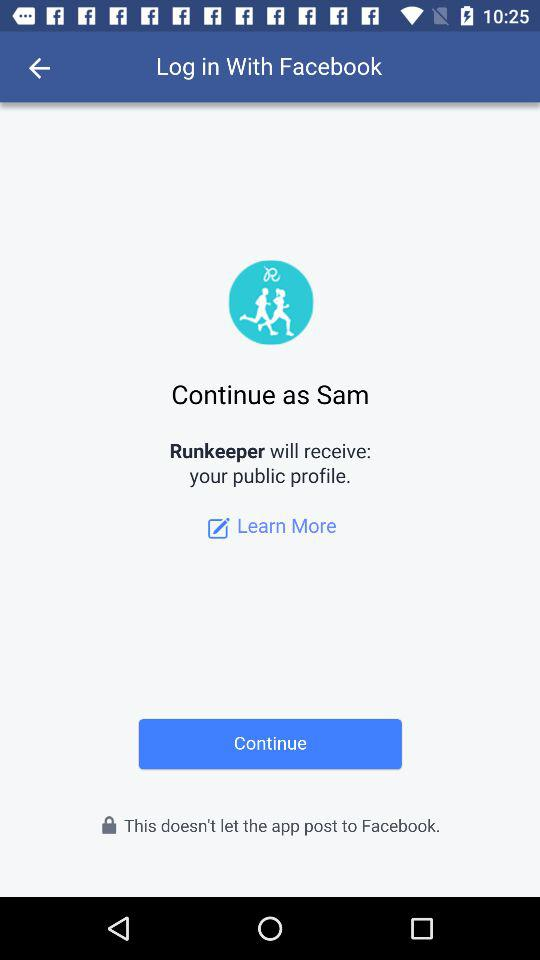What is the user name? The user name is Sam. 